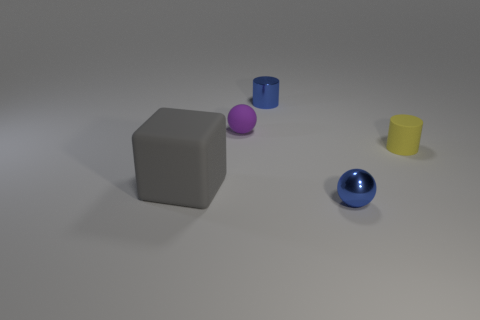Add 1 matte cylinders. How many objects exist? 6 Subtract all balls. How many objects are left? 3 Add 5 small metallic cylinders. How many small metallic cylinders are left? 6 Add 3 gray objects. How many gray objects exist? 4 Subtract 0 red cylinders. How many objects are left? 5 Subtract all big gray things. Subtract all small blue metallic objects. How many objects are left? 2 